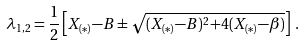<formula> <loc_0><loc_0><loc_500><loc_500>\lambda _ { 1 , 2 } = \frac { 1 } { 2 } \left [ X _ { ( * ) } { - } B \pm \sqrt { ( X _ { ( * ) } { - } B ) ^ { 2 } { + } 4 ( X _ { ( * ) } { - } \beta ) } \right ] \, .</formula> 